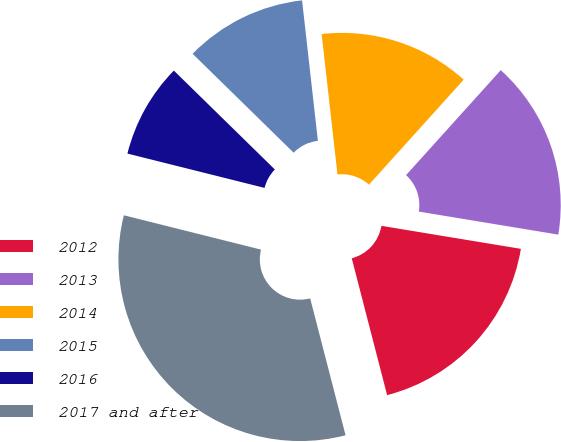Convert chart. <chart><loc_0><loc_0><loc_500><loc_500><pie_chart><fcel>2012<fcel>2013<fcel>2014<fcel>2015<fcel>2016<fcel>2017 and after<nl><fcel>18.37%<fcel>15.92%<fcel>13.47%<fcel>10.88%<fcel>8.43%<fcel>32.93%<nl></chart> 